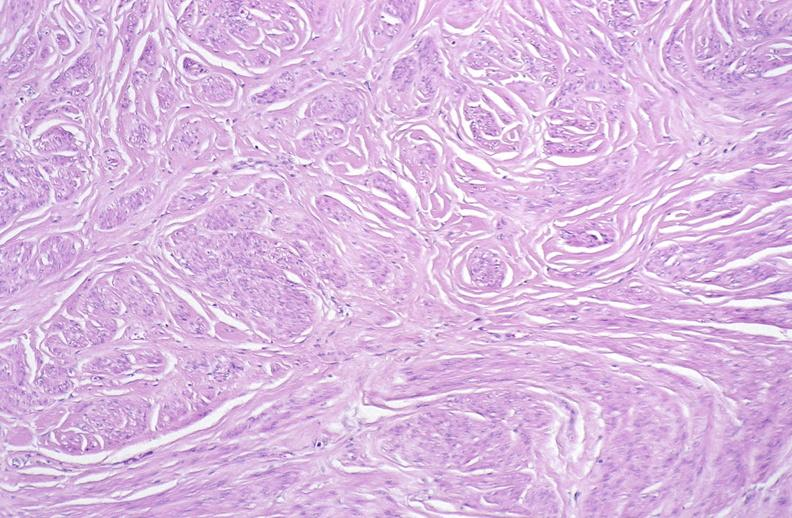does this image show leiomyoma, uterus?
Answer the question using a single word or phrase. Yes 